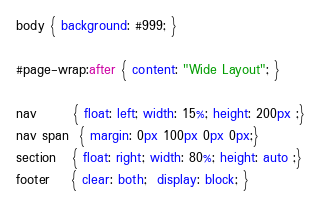<code> <loc_0><loc_0><loc_500><loc_500><_CSS_>body { background: #999; }

#page-wrap:after { content: "Wide Layout"; }

nav       { float: left; width: 15%; height: 200px ;}
nav span  { margin: 0px 100px 0px 0px;}
section   { float: right; width: 80%; height: auto ;}
footer    { clear: both;  display: block; }
</code> 